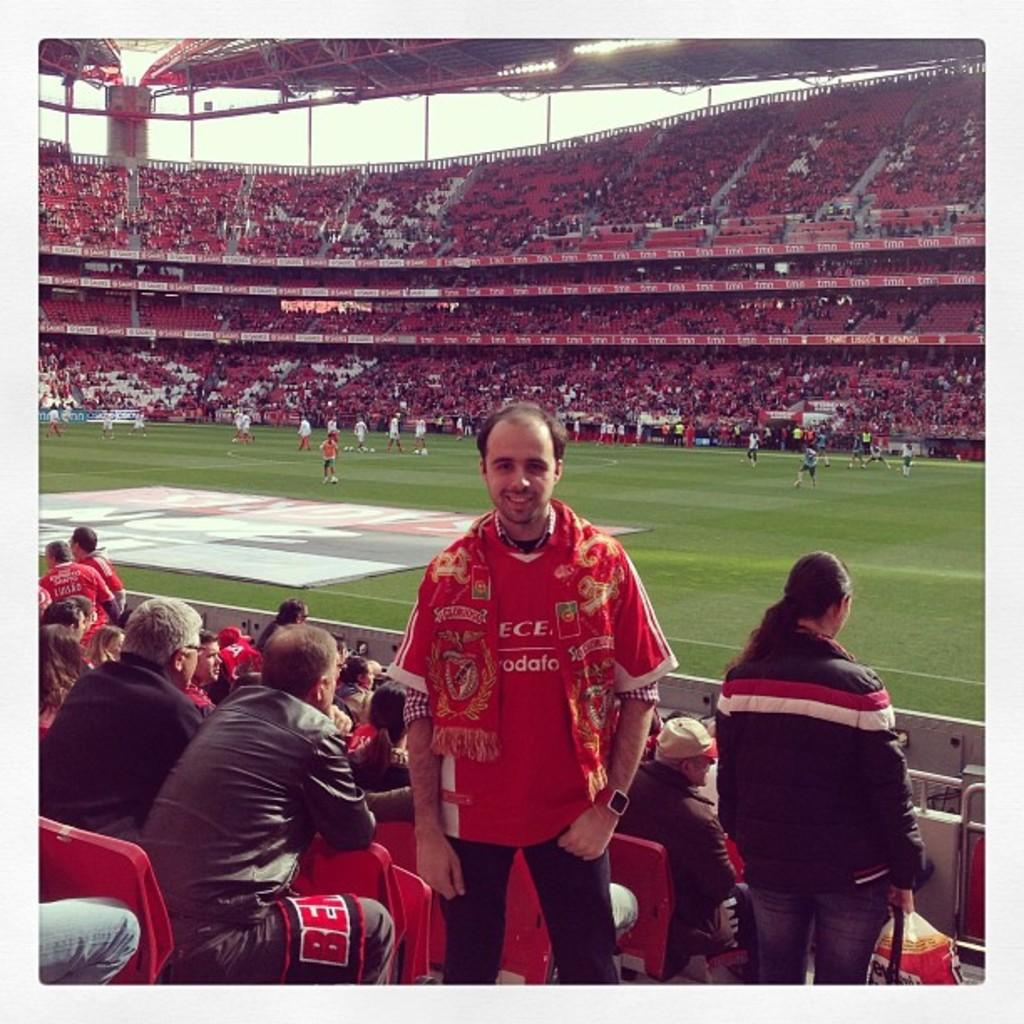What are the people in the image doing? There are people standing and sitting on red chairs in the image. Can you describe the chairs that the people are sitting on? The chairs are red. What else can be seen on the ground in the image? There are players on the ground. What is visible at the top of the image? Poles and lights are visible at the top of the image. What type of mint is growing on the ground in the image? There is no mint visible in the image; it features people standing, sitting, and players on the ground, along with red chairs, poles, and lights. 